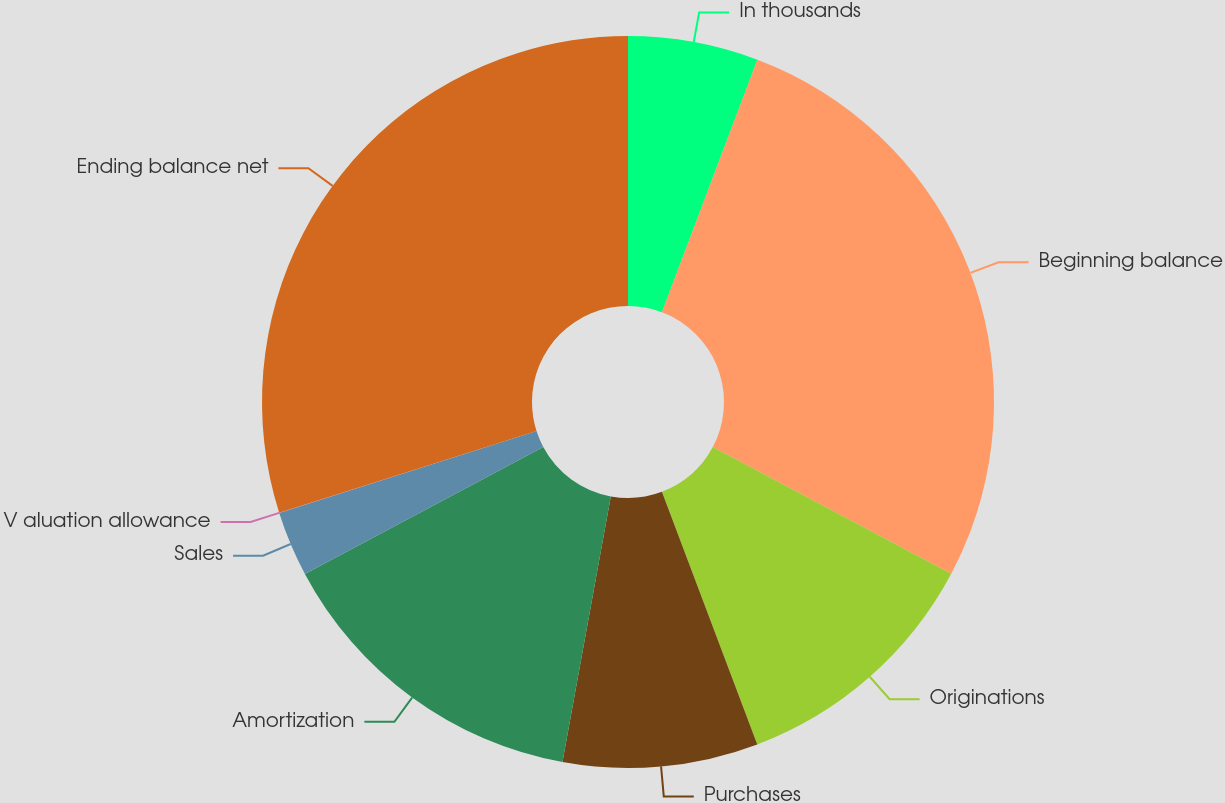<chart> <loc_0><loc_0><loc_500><loc_500><pie_chart><fcel>In thousands<fcel>Beginning balance<fcel>Originations<fcel>Purchases<fcel>Amortization<fcel>Sales<fcel>V aluation allowance<fcel>Ending balance net<nl><fcel>5.75%<fcel>27.02%<fcel>11.48%<fcel>8.61%<fcel>14.35%<fcel>2.88%<fcel>0.01%<fcel>29.89%<nl></chart> 